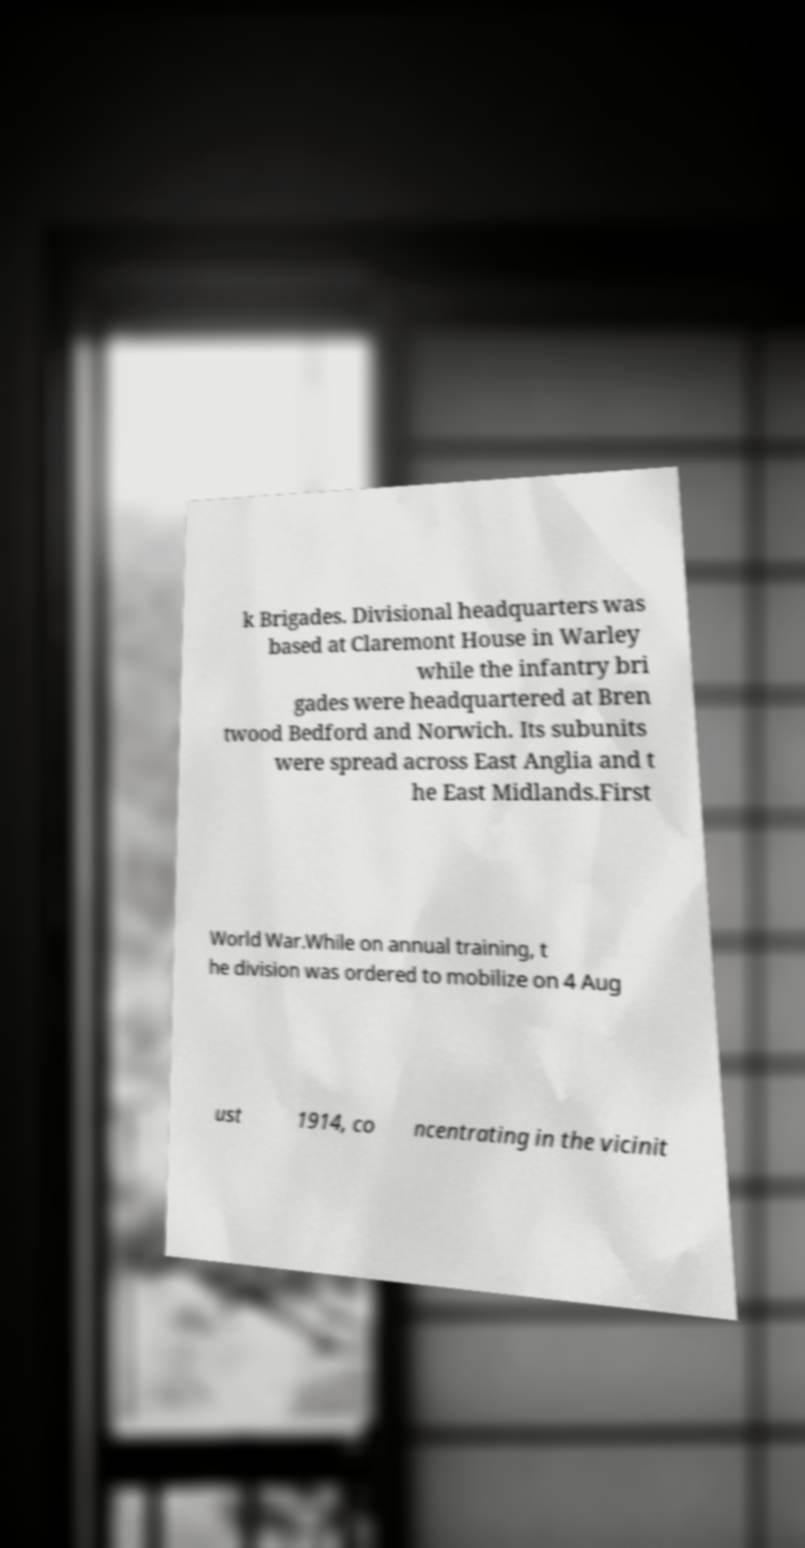I need the written content from this picture converted into text. Can you do that? k Brigades. Divisional headquarters was based at Claremont House in Warley while the infantry bri gades were headquartered at Bren twood Bedford and Norwich. Its subunits were spread across East Anglia and t he East Midlands.First World War.While on annual training, t he division was ordered to mobilize on 4 Aug ust 1914, co ncentrating in the vicinit 